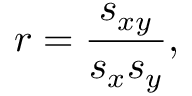<formula> <loc_0><loc_0><loc_500><loc_500>r = \frac { s _ { x y } } { s _ { x } s _ { y } } ,</formula> 